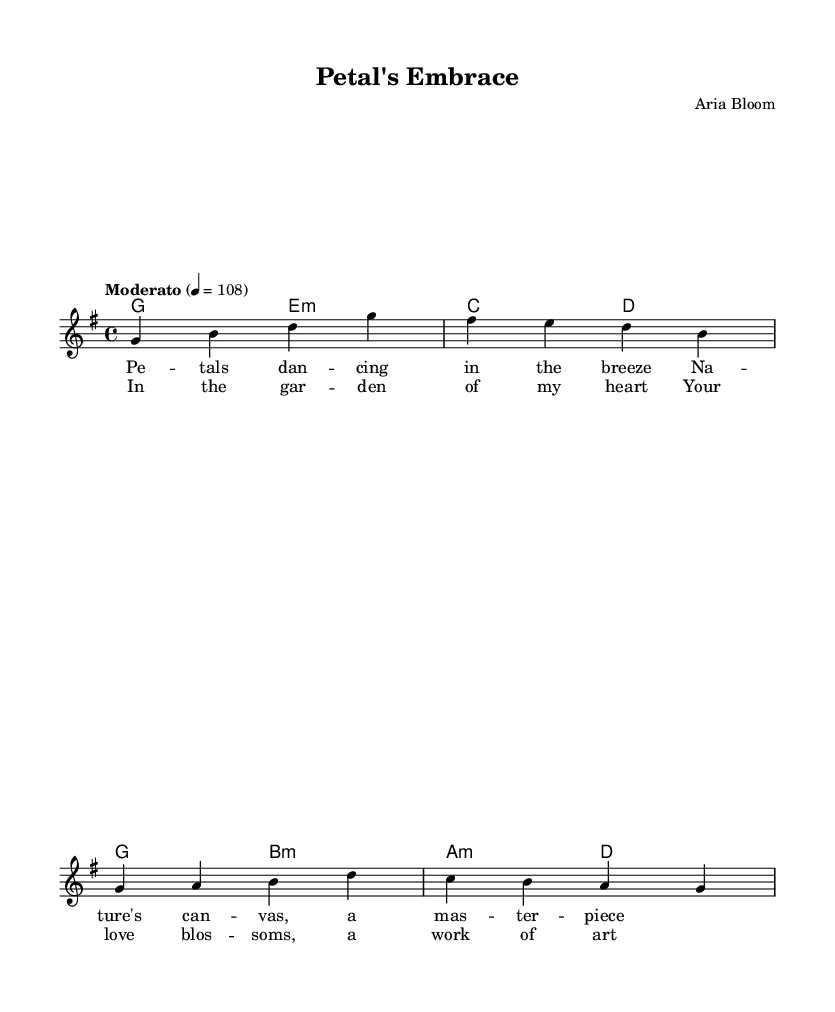what is the key signature of this music? The key signature is G major, which has one sharp (F#). This can be determined by looking at the key of the music noted at the beginning.
Answer: G major what is the time signature of this music? The time signature is 4/4, indicated at the beginning of the music under the global settings. This means there are four beats in a measure, and the quarter note gets one beat.
Answer: 4/4 what is the tempo marking of the piece? The tempo marking is "Moderato" with a tempo of 108 beats per minute, which are specified in the global section of the music. This guides the speed at which the piece should be played.
Answer: Moderato what is the title of the piece? The title is found in the header section of the sheet music, clearly marked as "Petal's Embrace", which describes the theme and essence of the song.
Answer: Petal's Embrace how many measures are in the chorus? The chorus consists of two four-bar sections, making a total of 8 measures. This includes analyzing the layout and counting the bars in the chorus lyric section.
Answer: 8 which chord appears first in the harmony section? The first chord in the harmony section is G major. This is determined by looking at the harmonies listed in the chord mode at the beginning, where the first notation represents G major.
Answer: G major how many verses are present in the song? There is one verse present in the song, as indicated in the structure of the sheet music where the verse is labeled and notated once.
Answer: 1 